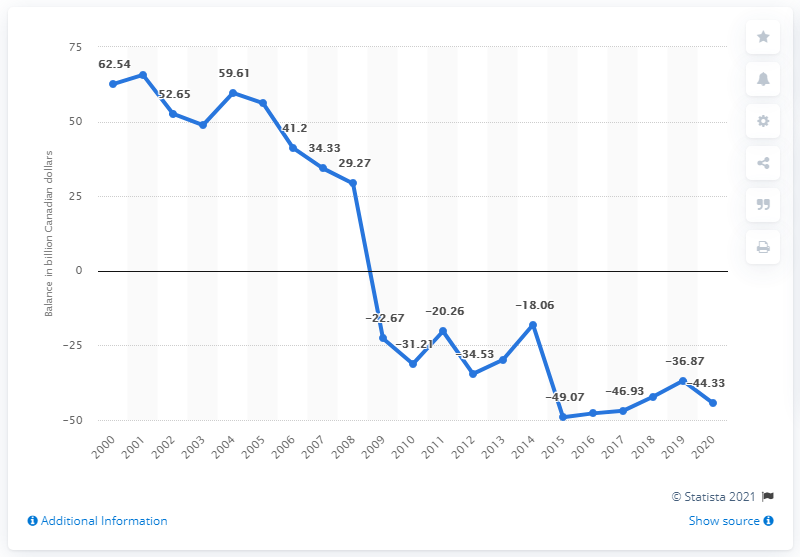Specify some key components in this picture. In 2008, Canada experienced a surplus of 29.27. 